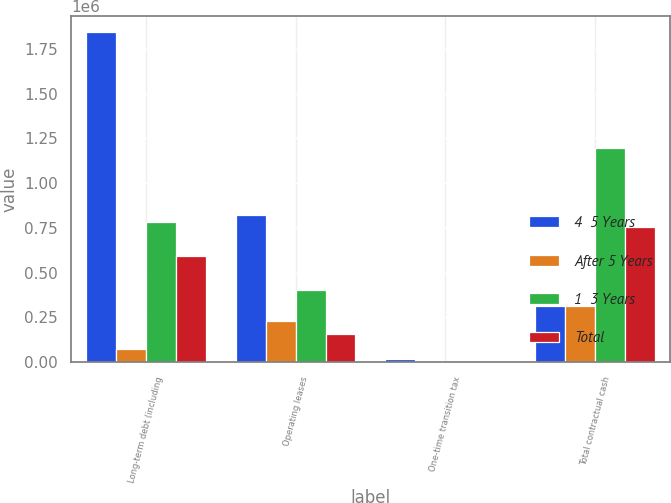<chart> <loc_0><loc_0><loc_500><loc_500><stacked_bar_chart><ecel><fcel>Long-term debt (including<fcel>Operating leases<fcel>One-time transition tax<fcel>Total contractual cash<nl><fcel>4  5 Years<fcel>1.84189e+06<fcel>820905<fcel>17721<fcel>314875<nl><fcel>After 5 Years<fcel>72688<fcel>230163<fcel>2448<fcel>314875<nl><fcel>1  3 Years<fcel>781969<fcel>401809<fcel>4053<fcel>1.19511e+06<nl><fcel>Total<fcel>591292<fcel>155120<fcel>3795<fcel>752612<nl></chart> 